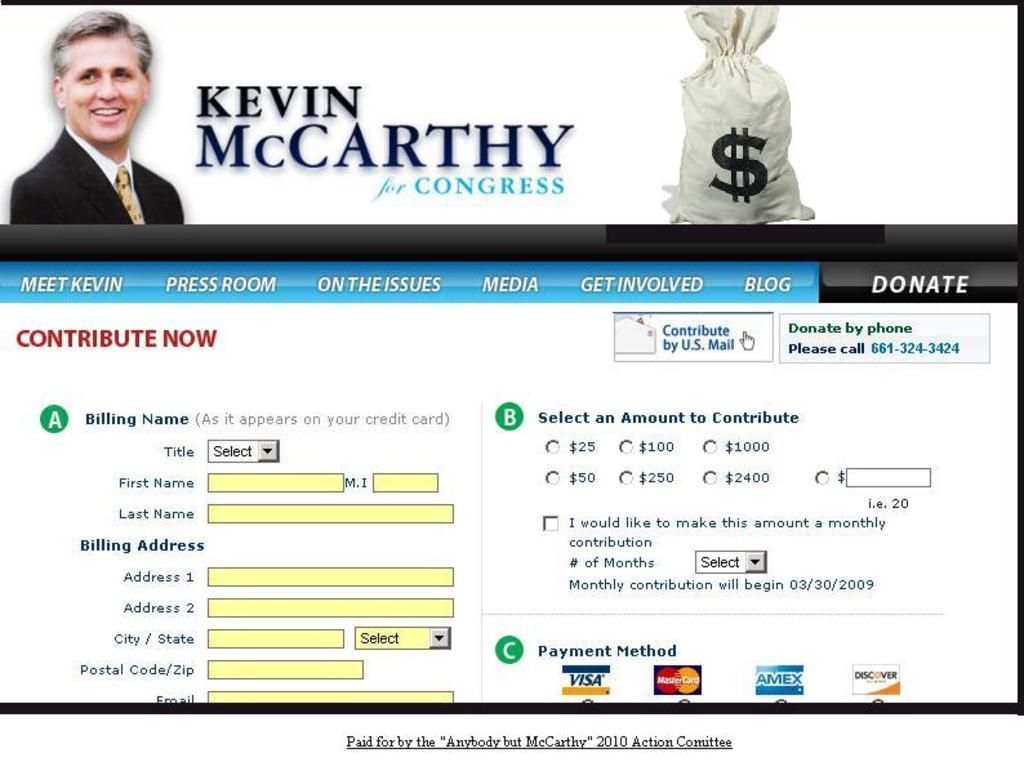In one or two sentences, can you explain what this image depicts? In this image we can see a display screen with some text and pictures on it. 